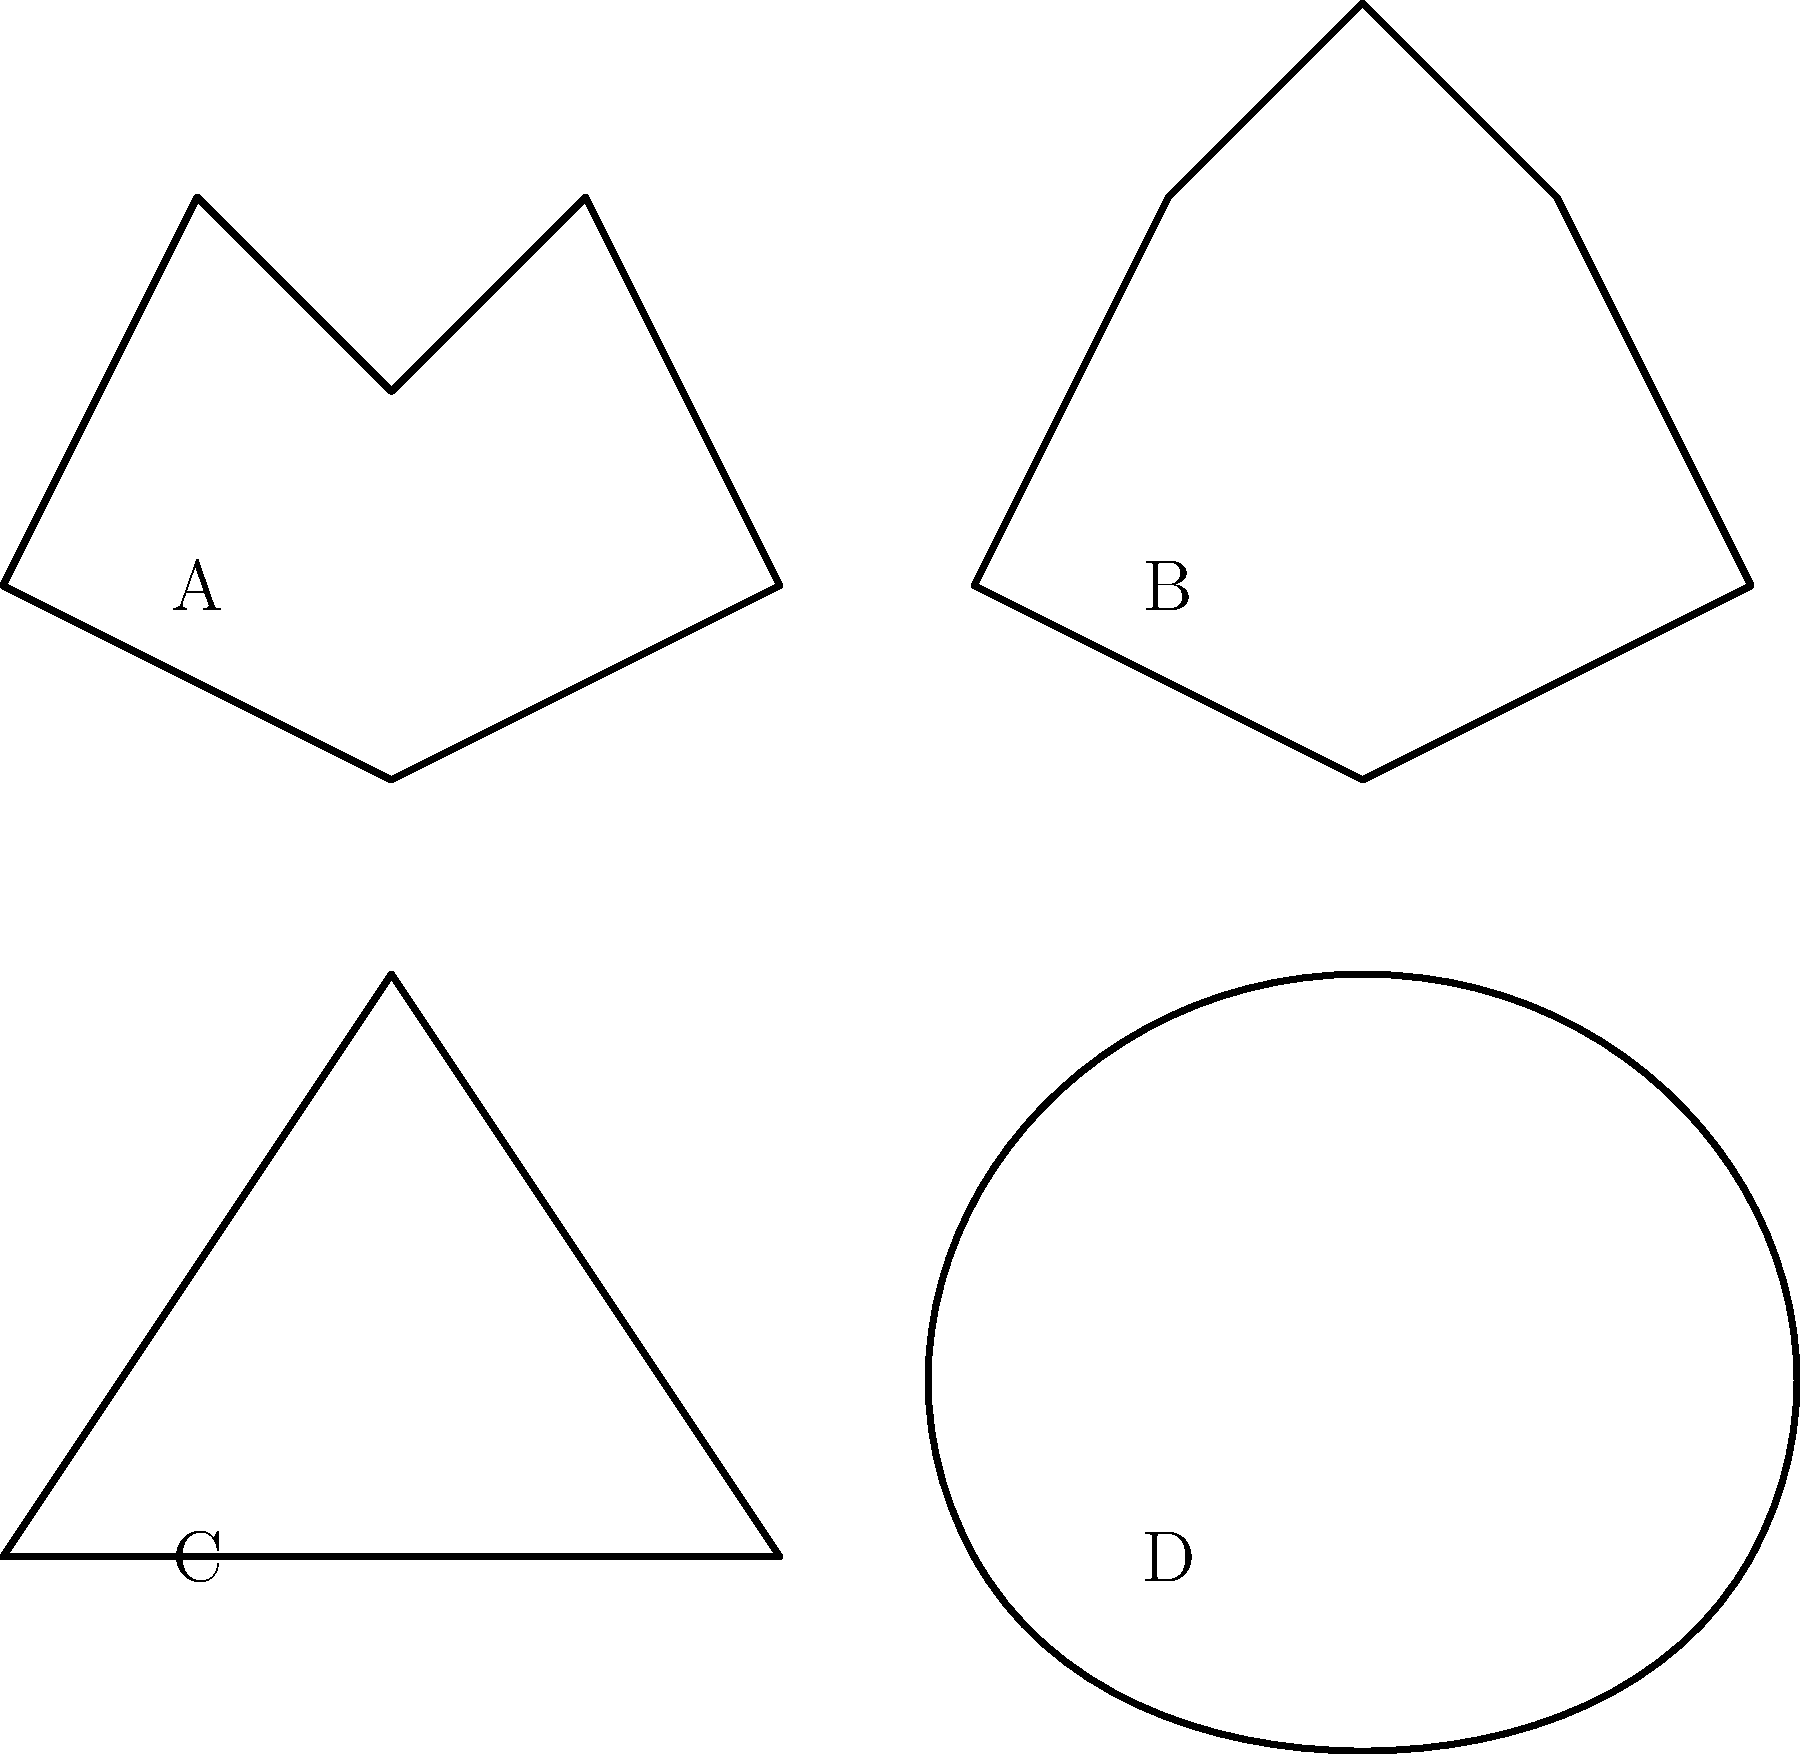Which leaf shape corresponds to a maple tree? To identify the maple leaf, let's examine the characteristics of each leaf shape:

1. Leaf A (top left): This leaf has deep lobes with rounded sinuses, typical of an oak leaf.

2. Leaf B (top right): This leaf has a distinctive shape with 5 pointed lobes, which is characteristic of a maple leaf. The lobes are arranged symmetrically, and the leaf has a broad, flat shape.

3. Leaf C (bottom left): This leaf has a simple, triangular shape with serrated edges, typical of a birch leaf.

4. Leaf D (bottom right): This leaf has an oval shape with doubly serrated edges and an asymmetrical base, which is characteristic of an elm leaf.

Based on these observations, the leaf shape that corresponds to a maple tree is Leaf B (top right). Maple leaves are known for their distinctive 5-lobed shape, which resembles the shape on the Canadian flag.
Answer: B 